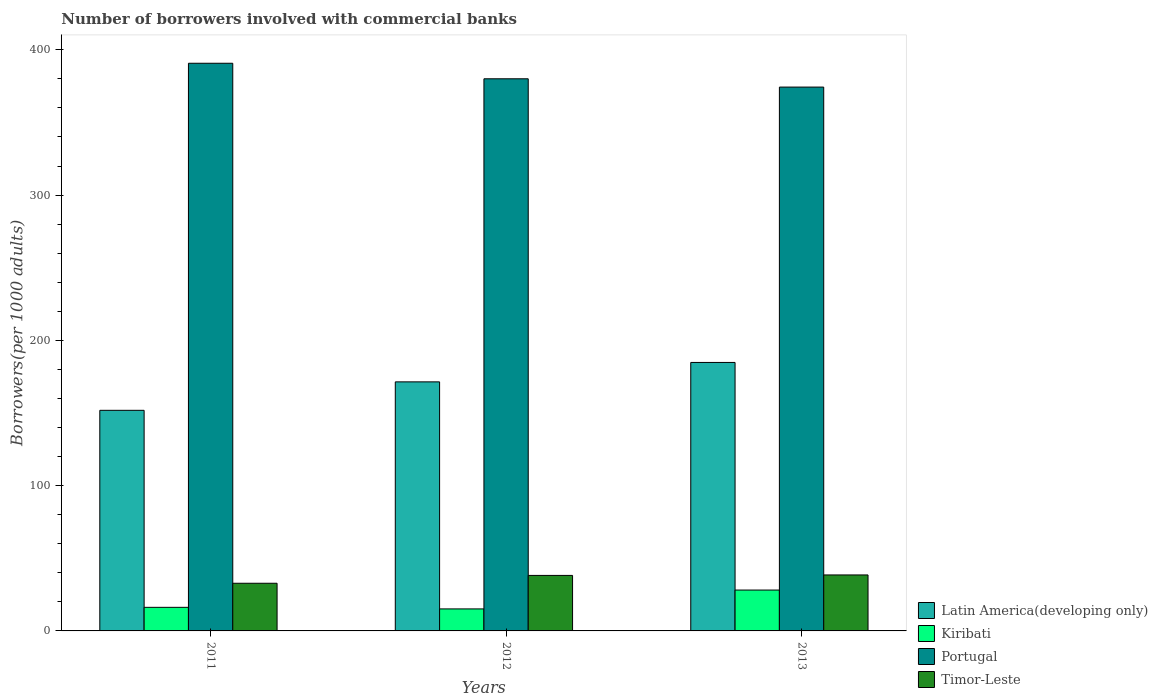How many different coloured bars are there?
Offer a very short reply. 4. How many groups of bars are there?
Offer a very short reply. 3. Are the number of bars per tick equal to the number of legend labels?
Keep it short and to the point. Yes. What is the number of borrowers involved with commercial banks in Timor-Leste in 2011?
Your response must be concise. 32.81. Across all years, what is the maximum number of borrowers involved with commercial banks in Latin America(developing only)?
Your answer should be very brief. 184.81. Across all years, what is the minimum number of borrowers involved with commercial banks in Timor-Leste?
Keep it short and to the point. 32.81. In which year was the number of borrowers involved with commercial banks in Kiribati minimum?
Your answer should be compact. 2012. What is the total number of borrowers involved with commercial banks in Kiribati in the graph?
Provide a succinct answer. 59.51. What is the difference between the number of borrowers involved with commercial banks in Timor-Leste in 2011 and that in 2012?
Offer a very short reply. -5.4. What is the difference between the number of borrowers involved with commercial banks in Latin America(developing only) in 2012 and the number of borrowers involved with commercial banks in Portugal in 2013?
Ensure brevity in your answer.  -202.91. What is the average number of borrowers involved with commercial banks in Kiribati per year?
Provide a short and direct response. 19.84. In the year 2013, what is the difference between the number of borrowers involved with commercial banks in Portugal and number of borrowers involved with commercial banks in Timor-Leste?
Provide a succinct answer. 335.81. What is the ratio of the number of borrowers involved with commercial banks in Latin America(developing only) in 2012 to that in 2013?
Your answer should be compact. 0.93. Is the number of borrowers involved with commercial banks in Latin America(developing only) in 2011 less than that in 2012?
Provide a succinct answer. Yes. What is the difference between the highest and the second highest number of borrowers involved with commercial banks in Kiribati?
Provide a succinct answer. 11.9. What is the difference between the highest and the lowest number of borrowers involved with commercial banks in Latin America(developing only)?
Keep it short and to the point. 32.96. In how many years, is the number of borrowers involved with commercial banks in Timor-Leste greater than the average number of borrowers involved with commercial banks in Timor-Leste taken over all years?
Ensure brevity in your answer.  2. Is the sum of the number of borrowers involved with commercial banks in Latin America(developing only) in 2011 and 2013 greater than the maximum number of borrowers involved with commercial banks in Portugal across all years?
Ensure brevity in your answer.  No. What does the 4th bar from the left in 2013 represents?
Ensure brevity in your answer.  Timor-Leste. What does the 1st bar from the right in 2011 represents?
Make the answer very short. Timor-Leste. Are all the bars in the graph horizontal?
Ensure brevity in your answer.  No. Does the graph contain any zero values?
Provide a short and direct response. No. How many legend labels are there?
Offer a very short reply. 4. What is the title of the graph?
Give a very brief answer. Number of borrowers involved with commercial banks. Does "Zambia" appear as one of the legend labels in the graph?
Offer a terse response. No. What is the label or title of the X-axis?
Make the answer very short. Years. What is the label or title of the Y-axis?
Provide a short and direct response. Borrowers(per 1000 adults). What is the Borrowers(per 1000 adults) of Latin America(developing only) in 2011?
Offer a very short reply. 151.85. What is the Borrowers(per 1000 adults) in Kiribati in 2011?
Keep it short and to the point. 16.23. What is the Borrowers(per 1000 adults) of Portugal in 2011?
Your response must be concise. 390.75. What is the Borrowers(per 1000 adults) of Timor-Leste in 2011?
Offer a terse response. 32.81. What is the Borrowers(per 1000 adults) of Latin America(developing only) in 2012?
Make the answer very short. 171.43. What is the Borrowers(per 1000 adults) of Kiribati in 2012?
Give a very brief answer. 15.15. What is the Borrowers(per 1000 adults) in Portugal in 2012?
Give a very brief answer. 380.06. What is the Borrowers(per 1000 adults) of Timor-Leste in 2012?
Keep it short and to the point. 38.21. What is the Borrowers(per 1000 adults) of Latin America(developing only) in 2013?
Your response must be concise. 184.81. What is the Borrowers(per 1000 adults) in Kiribati in 2013?
Ensure brevity in your answer.  28.13. What is the Borrowers(per 1000 adults) of Portugal in 2013?
Ensure brevity in your answer.  374.34. What is the Borrowers(per 1000 adults) in Timor-Leste in 2013?
Offer a very short reply. 38.53. Across all years, what is the maximum Borrowers(per 1000 adults) of Latin America(developing only)?
Make the answer very short. 184.81. Across all years, what is the maximum Borrowers(per 1000 adults) in Kiribati?
Ensure brevity in your answer.  28.13. Across all years, what is the maximum Borrowers(per 1000 adults) of Portugal?
Your response must be concise. 390.75. Across all years, what is the maximum Borrowers(per 1000 adults) in Timor-Leste?
Keep it short and to the point. 38.53. Across all years, what is the minimum Borrowers(per 1000 adults) in Latin America(developing only)?
Make the answer very short. 151.85. Across all years, what is the minimum Borrowers(per 1000 adults) of Kiribati?
Provide a short and direct response. 15.15. Across all years, what is the minimum Borrowers(per 1000 adults) in Portugal?
Make the answer very short. 374.34. Across all years, what is the minimum Borrowers(per 1000 adults) of Timor-Leste?
Offer a terse response. 32.81. What is the total Borrowers(per 1000 adults) in Latin America(developing only) in the graph?
Offer a very short reply. 508.09. What is the total Borrowers(per 1000 adults) of Kiribati in the graph?
Keep it short and to the point. 59.51. What is the total Borrowers(per 1000 adults) in Portugal in the graph?
Offer a very short reply. 1145.16. What is the total Borrowers(per 1000 adults) of Timor-Leste in the graph?
Your answer should be very brief. 109.55. What is the difference between the Borrowers(per 1000 adults) in Latin America(developing only) in 2011 and that in 2012?
Make the answer very short. -19.58. What is the difference between the Borrowers(per 1000 adults) of Kiribati in 2011 and that in 2012?
Your answer should be very brief. 1.08. What is the difference between the Borrowers(per 1000 adults) in Portugal in 2011 and that in 2012?
Give a very brief answer. 10.69. What is the difference between the Borrowers(per 1000 adults) in Timor-Leste in 2011 and that in 2012?
Provide a short and direct response. -5.4. What is the difference between the Borrowers(per 1000 adults) of Latin America(developing only) in 2011 and that in 2013?
Your response must be concise. -32.96. What is the difference between the Borrowers(per 1000 adults) of Kiribati in 2011 and that in 2013?
Your answer should be very brief. -11.9. What is the difference between the Borrowers(per 1000 adults) of Portugal in 2011 and that in 2013?
Make the answer very short. 16.4. What is the difference between the Borrowers(per 1000 adults) of Timor-Leste in 2011 and that in 2013?
Your answer should be very brief. -5.72. What is the difference between the Borrowers(per 1000 adults) in Latin America(developing only) in 2012 and that in 2013?
Your answer should be compact. -13.38. What is the difference between the Borrowers(per 1000 adults) of Kiribati in 2012 and that in 2013?
Make the answer very short. -12.98. What is the difference between the Borrowers(per 1000 adults) of Portugal in 2012 and that in 2013?
Offer a very short reply. 5.72. What is the difference between the Borrowers(per 1000 adults) of Timor-Leste in 2012 and that in 2013?
Keep it short and to the point. -0.32. What is the difference between the Borrowers(per 1000 adults) of Latin America(developing only) in 2011 and the Borrowers(per 1000 adults) of Kiribati in 2012?
Your answer should be compact. 136.7. What is the difference between the Borrowers(per 1000 adults) in Latin America(developing only) in 2011 and the Borrowers(per 1000 adults) in Portugal in 2012?
Your response must be concise. -228.21. What is the difference between the Borrowers(per 1000 adults) of Latin America(developing only) in 2011 and the Borrowers(per 1000 adults) of Timor-Leste in 2012?
Provide a succinct answer. 113.64. What is the difference between the Borrowers(per 1000 adults) of Kiribati in 2011 and the Borrowers(per 1000 adults) of Portugal in 2012?
Offer a very short reply. -363.83. What is the difference between the Borrowers(per 1000 adults) in Kiribati in 2011 and the Borrowers(per 1000 adults) in Timor-Leste in 2012?
Make the answer very short. -21.98. What is the difference between the Borrowers(per 1000 adults) in Portugal in 2011 and the Borrowers(per 1000 adults) in Timor-Leste in 2012?
Provide a succinct answer. 352.54. What is the difference between the Borrowers(per 1000 adults) of Latin America(developing only) in 2011 and the Borrowers(per 1000 adults) of Kiribati in 2013?
Provide a short and direct response. 123.72. What is the difference between the Borrowers(per 1000 adults) in Latin America(developing only) in 2011 and the Borrowers(per 1000 adults) in Portugal in 2013?
Keep it short and to the point. -222.5. What is the difference between the Borrowers(per 1000 adults) in Latin America(developing only) in 2011 and the Borrowers(per 1000 adults) in Timor-Leste in 2013?
Give a very brief answer. 113.31. What is the difference between the Borrowers(per 1000 adults) of Kiribati in 2011 and the Borrowers(per 1000 adults) of Portugal in 2013?
Provide a succinct answer. -358.11. What is the difference between the Borrowers(per 1000 adults) of Kiribati in 2011 and the Borrowers(per 1000 adults) of Timor-Leste in 2013?
Your answer should be very brief. -22.3. What is the difference between the Borrowers(per 1000 adults) of Portugal in 2011 and the Borrowers(per 1000 adults) of Timor-Leste in 2013?
Provide a short and direct response. 352.22. What is the difference between the Borrowers(per 1000 adults) in Latin America(developing only) in 2012 and the Borrowers(per 1000 adults) in Kiribati in 2013?
Your answer should be compact. 143.3. What is the difference between the Borrowers(per 1000 adults) in Latin America(developing only) in 2012 and the Borrowers(per 1000 adults) in Portugal in 2013?
Offer a very short reply. -202.91. What is the difference between the Borrowers(per 1000 adults) of Latin America(developing only) in 2012 and the Borrowers(per 1000 adults) of Timor-Leste in 2013?
Provide a succinct answer. 132.9. What is the difference between the Borrowers(per 1000 adults) of Kiribati in 2012 and the Borrowers(per 1000 adults) of Portugal in 2013?
Offer a very short reply. -359.19. What is the difference between the Borrowers(per 1000 adults) of Kiribati in 2012 and the Borrowers(per 1000 adults) of Timor-Leste in 2013?
Offer a terse response. -23.38. What is the difference between the Borrowers(per 1000 adults) of Portugal in 2012 and the Borrowers(per 1000 adults) of Timor-Leste in 2013?
Give a very brief answer. 341.53. What is the average Borrowers(per 1000 adults) in Latin America(developing only) per year?
Give a very brief answer. 169.36. What is the average Borrowers(per 1000 adults) in Kiribati per year?
Your answer should be very brief. 19.84. What is the average Borrowers(per 1000 adults) of Portugal per year?
Offer a very short reply. 381.72. What is the average Borrowers(per 1000 adults) in Timor-Leste per year?
Offer a very short reply. 36.52. In the year 2011, what is the difference between the Borrowers(per 1000 adults) in Latin America(developing only) and Borrowers(per 1000 adults) in Kiribati?
Your response must be concise. 135.62. In the year 2011, what is the difference between the Borrowers(per 1000 adults) in Latin America(developing only) and Borrowers(per 1000 adults) in Portugal?
Your response must be concise. -238.9. In the year 2011, what is the difference between the Borrowers(per 1000 adults) in Latin America(developing only) and Borrowers(per 1000 adults) in Timor-Leste?
Ensure brevity in your answer.  119.04. In the year 2011, what is the difference between the Borrowers(per 1000 adults) of Kiribati and Borrowers(per 1000 adults) of Portugal?
Ensure brevity in your answer.  -374.52. In the year 2011, what is the difference between the Borrowers(per 1000 adults) of Kiribati and Borrowers(per 1000 adults) of Timor-Leste?
Give a very brief answer. -16.58. In the year 2011, what is the difference between the Borrowers(per 1000 adults) of Portugal and Borrowers(per 1000 adults) of Timor-Leste?
Your response must be concise. 357.94. In the year 2012, what is the difference between the Borrowers(per 1000 adults) in Latin America(developing only) and Borrowers(per 1000 adults) in Kiribati?
Your response must be concise. 156.28. In the year 2012, what is the difference between the Borrowers(per 1000 adults) in Latin America(developing only) and Borrowers(per 1000 adults) in Portugal?
Your answer should be compact. -208.63. In the year 2012, what is the difference between the Borrowers(per 1000 adults) of Latin America(developing only) and Borrowers(per 1000 adults) of Timor-Leste?
Provide a succinct answer. 133.22. In the year 2012, what is the difference between the Borrowers(per 1000 adults) in Kiribati and Borrowers(per 1000 adults) in Portugal?
Provide a short and direct response. -364.91. In the year 2012, what is the difference between the Borrowers(per 1000 adults) in Kiribati and Borrowers(per 1000 adults) in Timor-Leste?
Your answer should be very brief. -23.06. In the year 2012, what is the difference between the Borrowers(per 1000 adults) in Portugal and Borrowers(per 1000 adults) in Timor-Leste?
Provide a succinct answer. 341.85. In the year 2013, what is the difference between the Borrowers(per 1000 adults) of Latin America(developing only) and Borrowers(per 1000 adults) of Kiribati?
Make the answer very short. 156.68. In the year 2013, what is the difference between the Borrowers(per 1000 adults) in Latin America(developing only) and Borrowers(per 1000 adults) in Portugal?
Offer a very short reply. -189.54. In the year 2013, what is the difference between the Borrowers(per 1000 adults) of Latin America(developing only) and Borrowers(per 1000 adults) of Timor-Leste?
Your answer should be compact. 146.27. In the year 2013, what is the difference between the Borrowers(per 1000 adults) in Kiribati and Borrowers(per 1000 adults) in Portugal?
Keep it short and to the point. -346.22. In the year 2013, what is the difference between the Borrowers(per 1000 adults) in Kiribati and Borrowers(per 1000 adults) in Timor-Leste?
Make the answer very short. -10.4. In the year 2013, what is the difference between the Borrowers(per 1000 adults) of Portugal and Borrowers(per 1000 adults) of Timor-Leste?
Ensure brevity in your answer.  335.81. What is the ratio of the Borrowers(per 1000 adults) of Latin America(developing only) in 2011 to that in 2012?
Your response must be concise. 0.89. What is the ratio of the Borrowers(per 1000 adults) in Kiribati in 2011 to that in 2012?
Your answer should be very brief. 1.07. What is the ratio of the Borrowers(per 1000 adults) in Portugal in 2011 to that in 2012?
Your response must be concise. 1.03. What is the ratio of the Borrowers(per 1000 adults) of Timor-Leste in 2011 to that in 2012?
Offer a terse response. 0.86. What is the ratio of the Borrowers(per 1000 adults) in Latin America(developing only) in 2011 to that in 2013?
Offer a very short reply. 0.82. What is the ratio of the Borrowers(per 1000 adults) of Kiribati in 2011 to that in 2013?
Your answer should be very brief. 0.58. What is the ratio of the Borrowers(per 1000 adults) in Portugal in 2011 to that in 2013?
Provide a short and direct response. 1.04. What is the ratio of the Borrowers(per 1000 adults) of Timor-Leste in 2011 to that in 2013?
Offer a very short reply. 0.85. What is the ratio of the Borrowers(per 1000 adults) of Latin America(developing only) in 2012 to that in 2013?
Offer a terse response. 0.93. What is the ratio of the Borrowers(per 1000 adults) of Kiribati in 2012 to that in 2013?
Offer a very short reply. 0.54. What is the ratio of the Borrowers(per 1000 adults) in Portugal in 2012 to that in 2013?
Provide a short and direct response. 1.02. What is the ratio of the Borrowers(per 1000 adults) of Timor-Leste in 2012 to that in 2013?
Give a very brief answer. 0.99. What is the difference between the highest and the second highest Borrowers(per 1000 adults) in Latin America(developing only)?
Ensure brevity in your answer.  13.38. What is the difference between the highest and the second highest Borrowers(per 1000 adults) in Kiribati?
Offer a terse response. 11.9. What is the difference between the highest and the second highest Borrowers(per 1000 adults) of Portugal?
Make the answer very short. 10.69. What is the difference between the highest and the second highest Borrowers(per 1000 adults) of Timor-Leste?
Offer a terse response. 0.32. What is the difference between the highest and the lowest Borrowers(per 1000 adults) in Latin America(developing only)?
Provide a succinct answer. 32.96. What is the difference between the highest and the lowest Borrowers(per 1000 adults) of Kiribati?
Your response must be concise. 12.98. What is the difference between the highest and the lowest Borrowers(per 1000 adults) of Portugal?
Your answer should be very brief. 16.4. What is the difference between the highest and the lowest Borrowers(per 1000 adults) in Timor-Leste?
Your answer should be very brief. 5.72. 